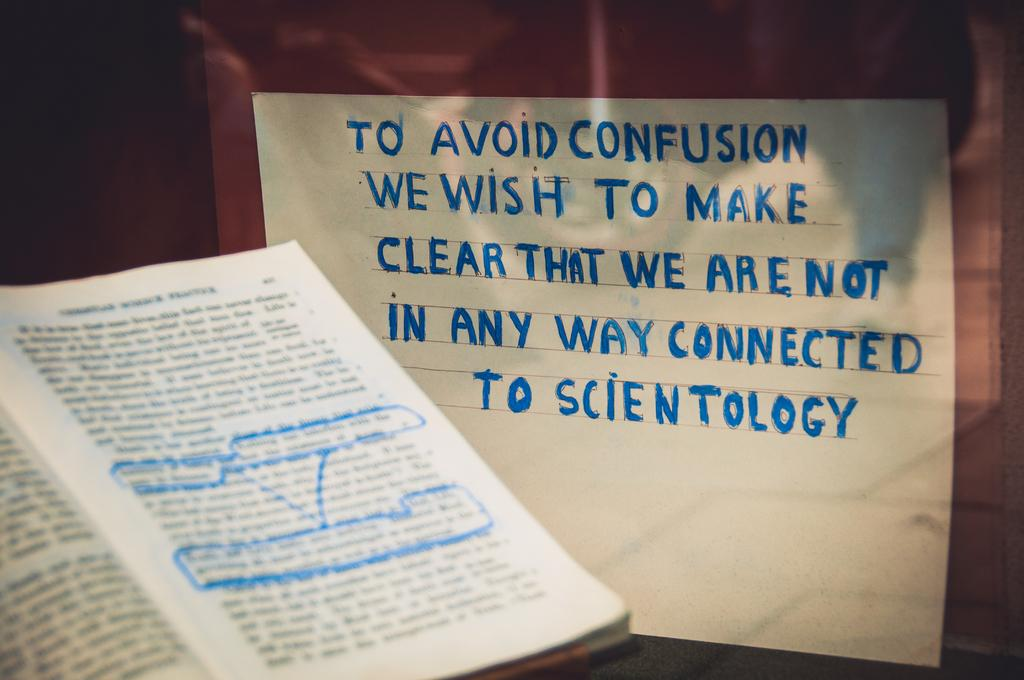<image>
Give a short and clear explanation of the subsequent image. a book next to a sign that talks about scientology 